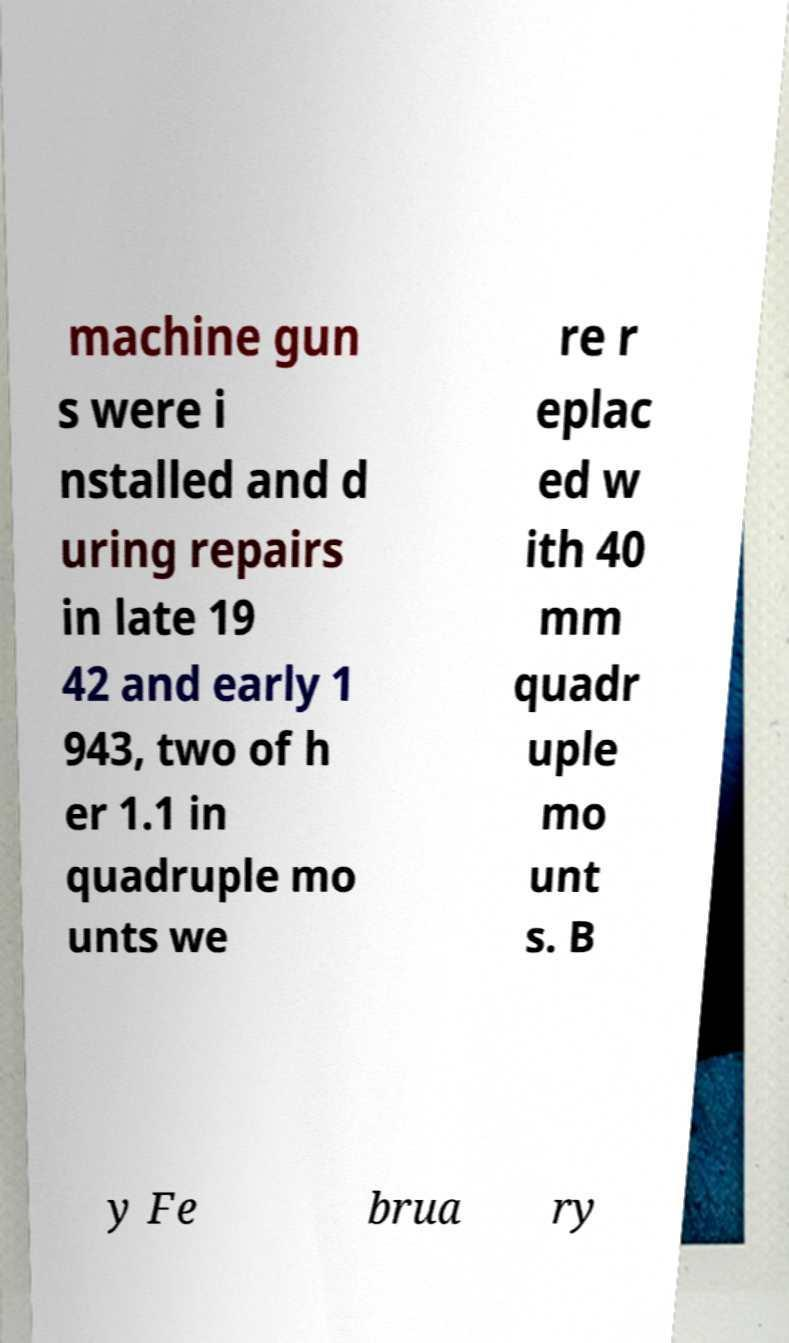Can you read and provide the text displayed in the image?This photo seems to have some interesting text. Can you extract and type it out for me? machine gun s were i nstalled and d uring repairs in late 19 42 and early 1 943, two of h er 1.1 in quadruple mo unts we re r eplac ed w ith 40 mm quadr uple mo unt s. B y Fe brua ry 